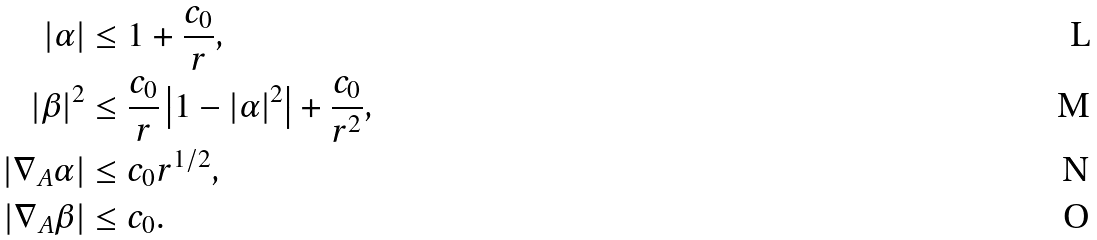<formula> <loc_0><loc_0><loc_500><loc_500>| \alpha | & \leq 1 + \frac { c _ { 0 } } { r } , \\ | \beta | ^ { 2 } & \leq \frac { c _ { 0 } } { r } \left | 1 - | \alpha | ^ { 2 } \right | + \frac { c _ { 0 } } { r ^ { 2 } } , \\ | \nabla _ { A } \alpha | & \leq c _ { 0 } r ^ { 1 / 2 } , \\ | \nabla _ { A } \beta | & \leq c _ { 0 } .</formula> 